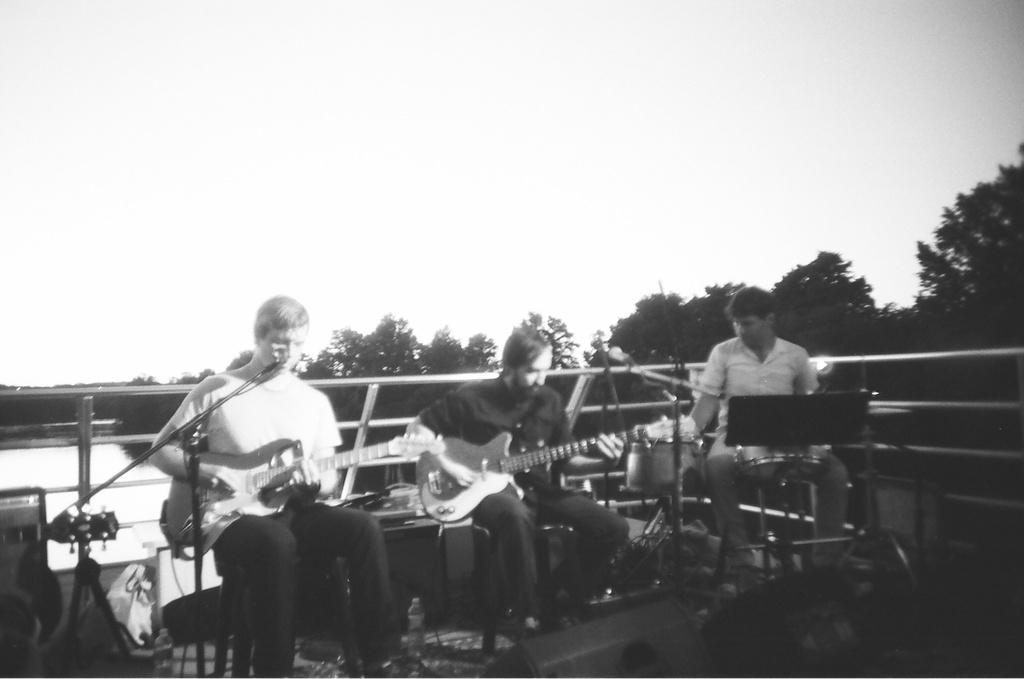Could you give a brief overview of what you see in this image? Here we can see a group of people are sitting on the chair, and playing the guitar, and here are the drums, and at back here is the water, and here are the trees and at above here is the sky. 